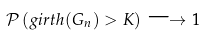Convert formula to latex. <formula><loc_0><loc_0><loc_500><loc_500>\mathcal { P } \left ( g i r t h ( G _ { n } ) > K \right ) \longrightarrow 1</formula> 